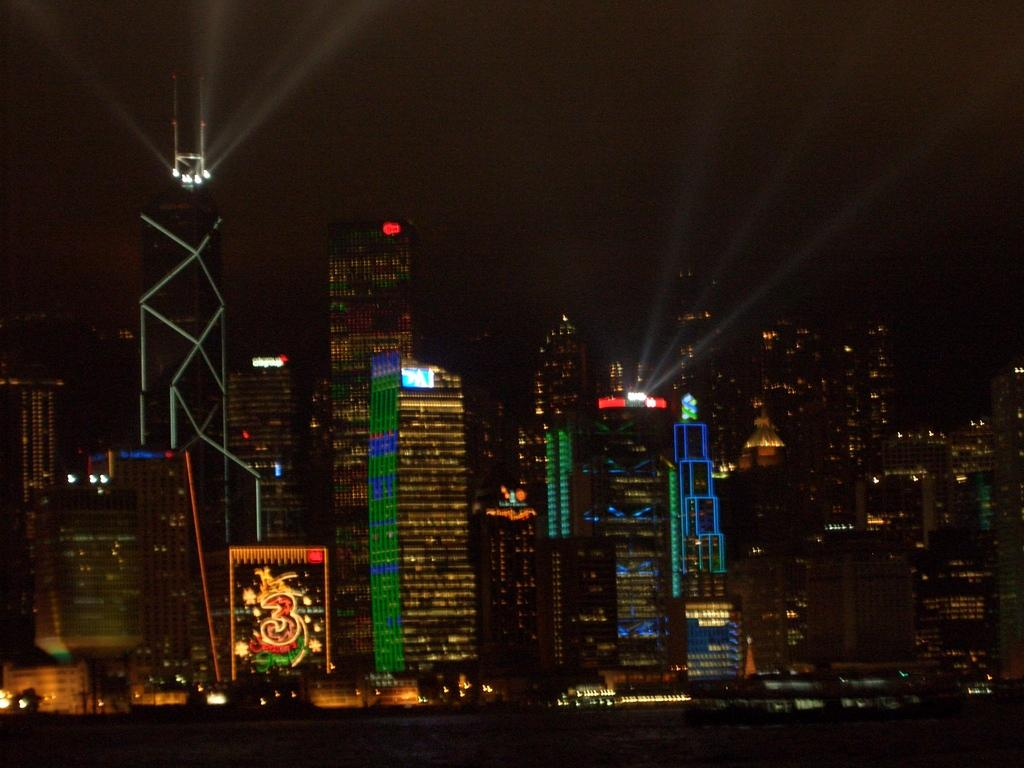What can be seen in the distance in the image? There are buildings in the background of the image. What feature do the buildings have? The buildings have lights on them. Is there any text or number visible in the image? Yes, a number is visible in the image. Can you tell me how many oranges are on the table in the image? There is no table or oranges present in the image. What type of club is featured in the image? There is no club present in the image. 